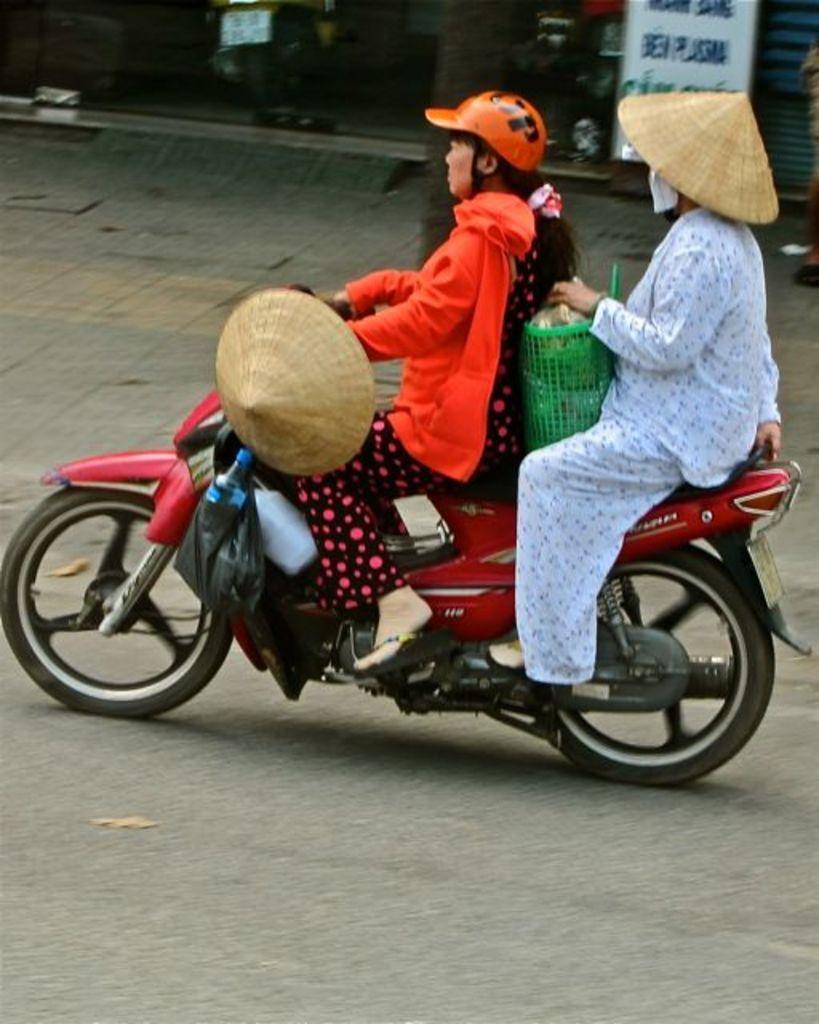In one or two sentences, can you explain what this image depicts? As we can see in the image there are two people sitting on motorcycle and there is a road over here. 